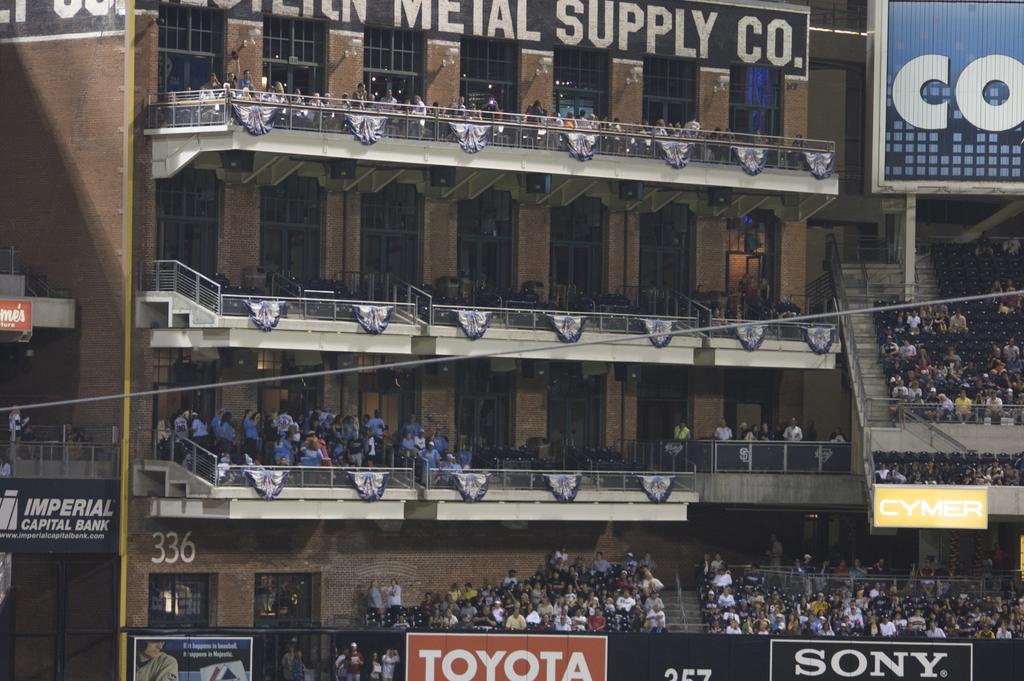What type of building is shown in the image? The image depicts a stadium building. Can you describe the people inside the stadium? There is a large crowd in each floor of the stadium. What else can be seen in the foreground of the image? Company names are visible in the foreground of the image. How many dolls are sitting on the elbow of the person in the image? There are no dolls or elbows visible in the image; it depicts a stadium building with a large crowd inside. 